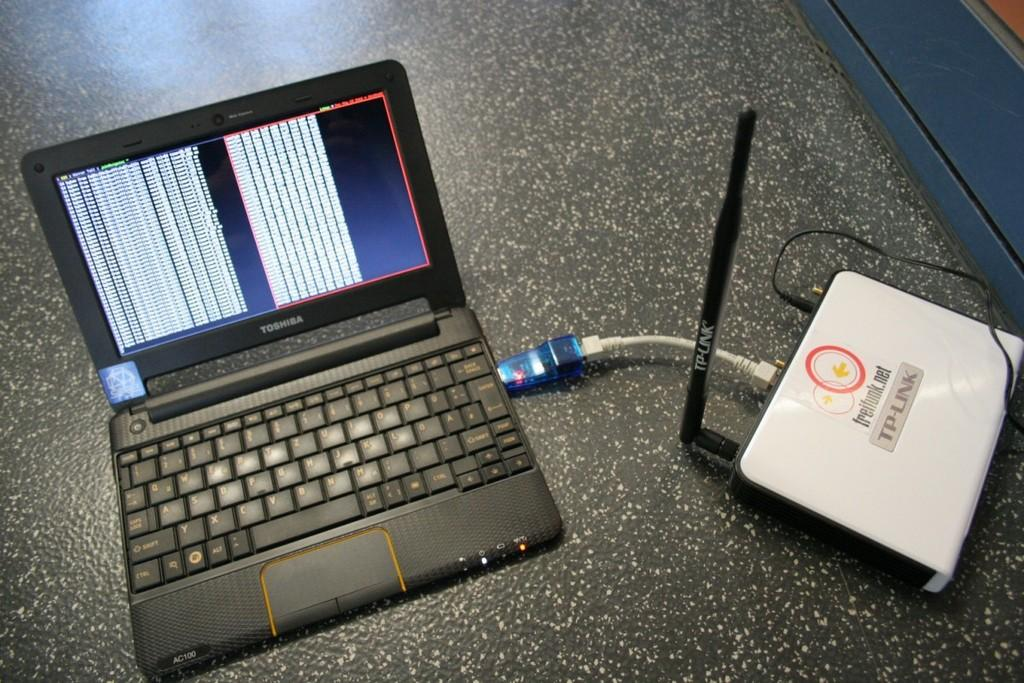<image>
Render a clear and concise summary of the photo. toshiba laptop plugged into a tp-link router to power up 